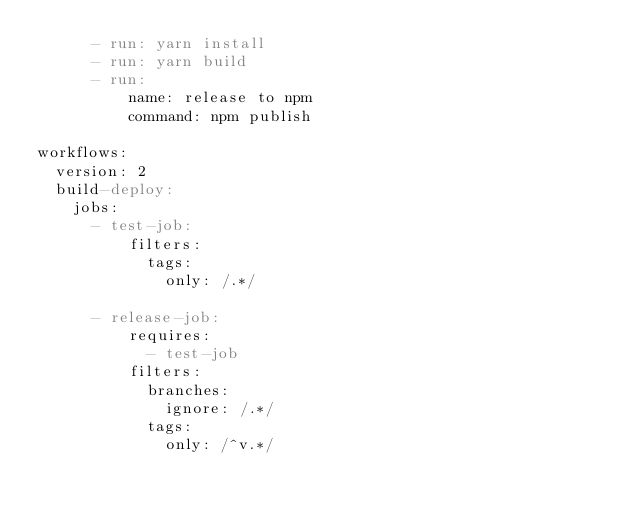Convert code to text. <code><loc_0><loc_0><loc_500><loc_500><_YAML_>      - run: yarn install
      - run: yarn build
      - run:
          name: release to npm
          command: npm publish

workflows:
  version: 2
  build-deploy:
    jobs:
      - test-job:
          filters:
            tags:
              only: /.*/

      - release-job:
          requires:
            - test-job
          filters:
            branches:
              ignore: /.*/
            tags:
              only: /^v.*/
</code> 